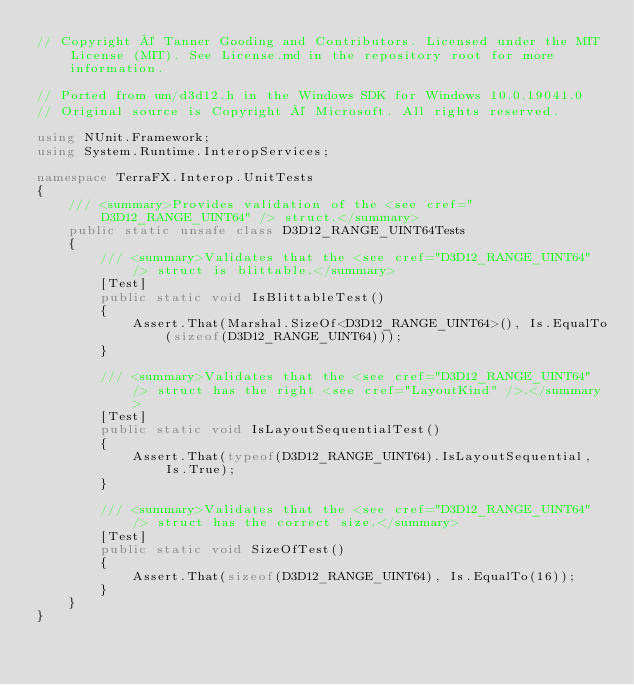Convert code to text. <code><loc_0><loc_0><loc_500><loc_500><_C#_>// Copyright © Tanner Gooding and Contributors. Licensed under the MIT License (MIT). See License.md in the repository root for more information.

// Ported from um/d3d12.h in the Windows SDK for Windows 10.0.19041.0
// Original source is Copyright © Microsoft. All rights reserved.

using NUnit.Framework;
using System.Runtime.InteropServices;

namespace TerraFX.Interop.UnitTests
{
    /// <summary>Provides validation of the <see cref="D3D12_RANGE_UINT64" /> struct.</summary>
    public static unsafe class D3D12_RANGE_UINT64Tests
    {
        /// <summary>Validates that the <see cref="D3D12_RANGE_UINT64" /> struct is blittable.</summary>
        [Test]
        public static void IsBlittableTest()
        {
            Assert.That(Marshal.SizeOf<D3D12_RANGE_UINT64>(), Is.EqualTo(sizeof(D3D12_RANGE_UINT64)));
        }

        /// <summary>Validates that the <see cref="D3D12_RANGE_UINT64" /> struct has the right <see cref="LayoutKind" />.</summary>
        [Test]
        public static void IsLayoutSequentialTest()
        {
            Assert.That(typeof(D3D12_RANGE_UINT64).IsLayoutSequential, Is.True);
        }

        /// <summary>Validates that the <see cref="D3D12_RANGE_UINT64" /> struct has the correct size.</summary>
        [Test]
        public static void SizeOfTest()
        {
            Assert.That(sizeof(D3D12_RANGE_UINT64), Is.EqualTo(16));
        }
    }
}
</code> 